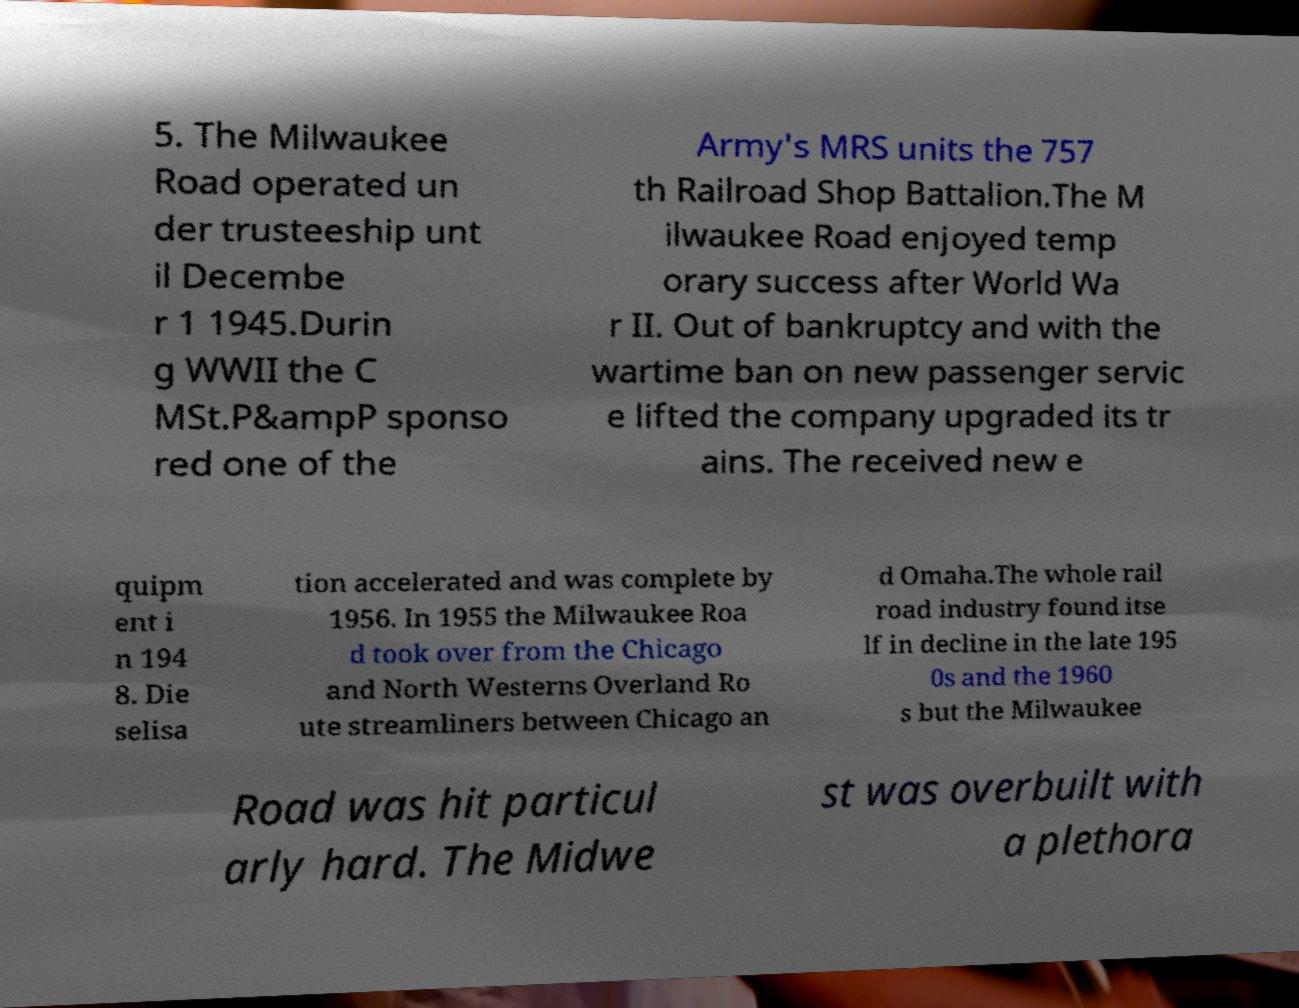Could you extract and type out the text from this image? 5. The Milwaukee Road operated un der trusteeship unt il Decembe r 1 1945.Durin g WWII the C MSt.P&ampP sponso red one of the Army's MRS units the 757 th Railroad Shop Battalion.The M ilwaukee Road enjoyed temp orary success after World Wa r II. Out of bankruptcy and with the wartime ban on new passenger servic e lifted the company upgraded its tr ains. The received new e quipm ent i n 194 8. Die selisa tion accelerated and was complete by 1956. In 1955 the Milwaukee Roa d took over from the Chicago and North Westerns Overland Ro ute streamliners between Chicago an d Omaha.The whole rail road industry found itse lf in decline in the late 195 0s and the 1960 s but the Milwaukee Road was hit particul arly hard. The Midwe st was overbuilt with a plethora 